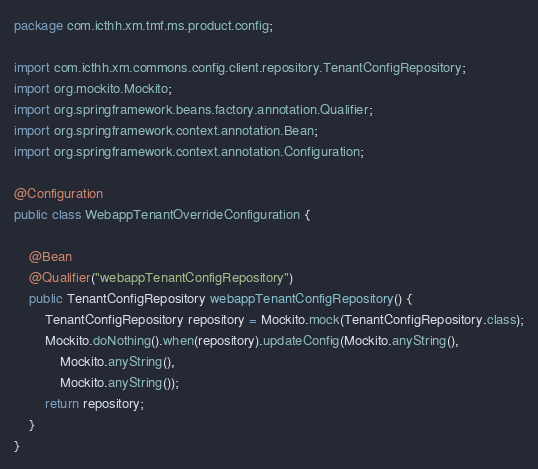<code> <loc_0><loc_0><loc_500><loc_500><_Java_>package com.icthh.xm.tmf.ms.product.config;

import com.icthh.xm.commons.config.client.repository.TenantConfigRepository;
import org.mockito.Mockito;
import org.springframework.beans.factory.annotation.Qualifier;
import org.springframework.context.annotation.Bean;
import org.springframework.context.annotation.Configuration;

@Configuration
public class WebappTenantOverrideConfiguration {

    @Bean
    @Qualifier("webappTenantConfigRepository")
    public TenantConfigRepository webappTenantConfigRepository() {
        TenantConfigRepository repository = Mockito.mock(TenantConfigRepository.class);
        Mockito.doNothing().when(repository).updateConfig(Mockito.anyString(),
            Mockito.anyString(),
            Mockito.anyString());
        return repository;
    }
}
</code> 